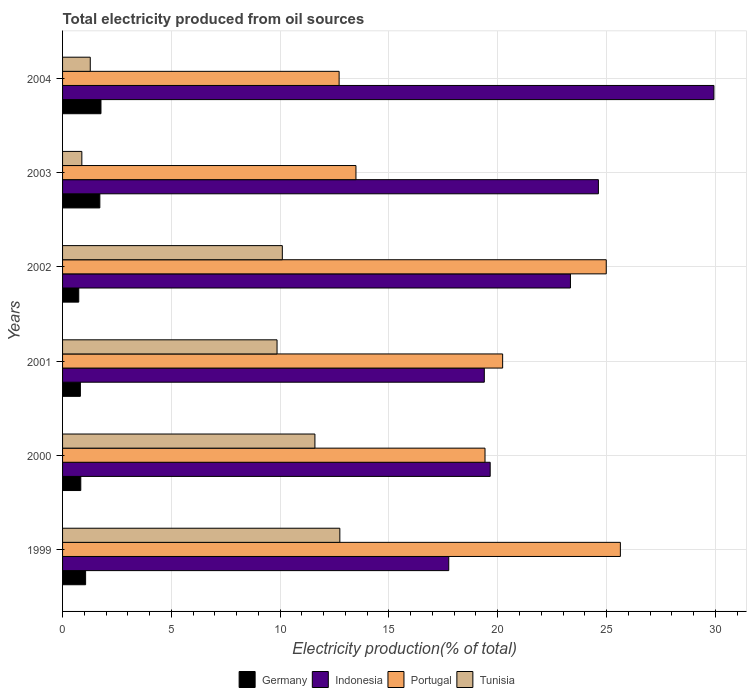What is the label of the 3rd group of bars from the top?
Offer a very short reply. 2002. In how many cases, is the number of bars for a given year not equal to the number of legend labels?
Offer a very short reply. 0. What is the total electricity produced in Indonesia in 2000?
Provide a succinct answer. 19.65. Across all years, what is the maximum total electricity produced in Tunisia?
Your answer should be compact. 12.74. Across all years, what is the minimum total electricity produced in Germany?
Provide a succinct answer. 0.74. What is the total total electricity produced in Tunisia in the graph?
Offer a terse response. 46.46. What is the difference between the total electricity produced in Portugal in 2003 and that in 2004?
Provide a succinct answer. 0.77. What is the difference between the total electricity produced in Portugal in 1999 and the total electricity produced in Indonesia in 2003?
Offer a terse response. 1.01. What is the average total electricity produced in Portugal per year?
Ensure brevity in your answer.  19.41. In the year 2003, what is the difference between the total electricity produced in Tunisia and total electricity produced in Indonesia?
Your answer should be very brief. -23.74. In how many years, is the total electricity produced in Tunisia greater than 28 %?
Provide a short and direct response. 0. What is the ratio of the total electricity produced in Germany in 2001 to that in 2002?
Your response must be concise. 1.1. Is the difference between the total electricity produced in Tunisia in 2000 and 2003 greater than the difference between the total electricity produced in Indonesia in 2000 and 2003?
Your answer should be very brief. Yes. What is the difference between the highest and the second highest total electricity produced in Germany?
Your answer should be very brief. 0.05. What is the difference between the highest and the lowest total electricity produced in Portugal?
Your answer should be very brief. 12.93. Is the sum of the total electricity produced in Portugal in 2001 and 2003 greater than the maximum total electricity produced in Tunisia across all years?
Provide a succinct answer. Yes. Is it the case that in every year, the sum of the total electricity produced in Germany and total electricity produced in Indonesia is greater than the sum of total electricity produced in Portugal and total electricity produced in Tunisia?
Your answer should be very brief. No. What does the 1st bar from the top in 2001 represents?
Provide a succinct answer. Tunisia. What does the 3rd bar from the bottom in 1999 represents?
Offer a very short reply. Portugal. Is it the case that in every year, the sum of the total electricity produced in Portugal and total electricity produced in Indonesia is greater than the total electricity produced in Tunisia?
Ensure brevity in your answer.  Yes. How many bars are there?
Provide a succinct answer. 24. Are all the bars in the graph horizontal?
Your response must be concise. Yes. How many years are there in the graph?
Your answer should be compact. 6. What is the difference between two consecutive major ticks on the X-axis?
Offer a terse response. 5. Does the graph contain any zero values?
Your response must be concise. No. Does the graph contain grids?
Give a very brief answer. Yes. Where does the legend appear in the graph?
Offer a very short reply. Bottom center. How many legend labels are there?
Your answer should be compact. 4. What is the title of the graph?
Ensure brevity in your answer.  Total electricity produced from oil sources. What is the Electricity production(% of total) in Germany in 1999?
Offer a terse response. 1.06. What is the Electricity production(% of total) of Indonesia in 1999?
Provide a short and direct response. 17.75. What is the Electricity production(% of total) in Portugal in 1999?
Your answer should be very brief. 25.64. What is the Electricity production(% of total) of Tunisia in 1999?
Make the answer very short. 12.74. What is the Electricity production(% of total) of Germany in 2000?
Ensure brevity in your answer.  0.84. What is the Electricity production(% of total) of Indonesia in 2000?
Offer a very short reply. 19.65. What is the Electricity production(% of total) of Portugal in 2000?
Offer a very short reply. 19.42. What is the Electricity production(% of total) of Tunisia in 2000?
Offer a very short reply. 11.6. What is the Electricity production(% of total) of Germany in 2001?
Offer a very short reply. 0.82. What is the Electricity production(% of total) in Indonesia in 2001?
Make the answer very short. 19.38. What is the Electricity production(% of total) of Portugal in 2001?
Give a very brief answer. 20.23. What is the Electricity production(% of total) of Tunisia in 2001?
Offer a very short reply. 9.86. What is the Electricity production(% of total) in Germany in 2002?
Make the answer very short. 0.74. What is the Electricity production(% of total) of Indonesia in 2002?
Your answer should be compact. 23.34. What is the Electricity production(% of total) in Portugal in 2002?
Your response must be concise. 24.99. What is the Electricity production(% of total) in Tunisia in 2002?
Your response must be concise. 10.1. What is the Electricity production(% of total) of Germany in 2003?
Your answer should be very brief. 1.71. What is the Electricity production(% of total) in Indonesia in 2003?
Make the answer very short. 24.63. What is the Electricity production(% of total) in Portugal in 2003?
Ensure brevity in your answer.  13.48. What is the Electricity production(% of total) of Tunisia in 2003?
Provide a succinct answer. 0.89. What is the Electricity production(% of total) in Germany in 2004?
Provide a short and direct response. 1.77. What is the Electricity production(% of total) in Indonesia in 2004?
Your answer should be very brief. 29.94. What is the Electricity production(% of total) of Portugal in 2004?
Your answer should be compact. 12.71. What is the Electricity production(% of total) of Tunisia in 2004?
Your answer should be very brief. 1.27. Across all years, what is the maximum Electricity production(% of total) of Germany?
Provide a succinct answer. 1.77. Across all years, what is the maximum Electricity production(% of total) of Indonesia?
Your answer should be very brief. 29.94. Across all years, what is the maximum Electricity production(% of total) of Portugal?
Your response must be concise. 25.64. Across all years, what is the maximum Electricity production(% of total) of Tunisia?
Provide a succinct answer. 12.74. Across all years, what is the minimum Electricity production(% of total) of Germany?
Keep it short and to the point. 0.74. Across all years, what is the minimum Electricity production(% of total) in Indonesia?
Provide a short and direct response. 17.75. Across all years, what is the minimum Electricity production(% of total) of Portugal?
Make the answer very short. 12.71. Across all years, what is the minimum Electricity production(% of total) of Tunisia?
Your answer should be compact. 0.89. What is the total Electricity production(% of total) in Germany in the graph?
Offer a very short reply. 6.94. What is the total Electricity production(% of total) in Indonesia in the graph?
Keep it short and to the point. 134.69. What is the total Electricity production(% of total) in Portugal in the graph?
Your answer should be very brief. 116.46. What is the total Electricity production(% of total) in Tunisia in the graph?
Your answer should be very brief. 46.46. What is the difference between the Electricity production(% of total) of Germany in 1999 and that in 2000?
Your response must be concise. 0.22. What is the difference between the Electricity production(% of total) in Indonesia in 1999 and that in 2000?
Offer a very short reply. -1.91. What is the difference between the Electricity production(% of total) in Portugal in 1999 and that in 2000?
Provide a short and direct response. 6.22. What is the difference between the Electricity production(% of total) in Tunisia in 1999 and that in 2000?
Offer a very short reply. 1.15. What is the difference between the Electricity production(% of total) in Germany in 1999 and that in 2001?
Offer a very short reply. 0.24. What is the difference between the Electricity production(% of total) in Indonesia in 1999 and that in 2001?
Offer a terse response. -1.64. What is the difference between the Electricity production(% of total) in Portugal in 1999 and that in 2001?
Give a very brief answer. 5.41. What is the difference between the Electricity production(% of total) in Tunisia in 1999 and that in 2001?
Ensure brevity in your answer.  2.89. What is the difference between the Electricity production(% of total) in Germany in 1999 and that in 2002?
Make the answer very short. 0.32. What is the difference between the Electricity production(% of total) in Indonesia in 1999 and that in 2002?
Provide a succinct answer. -5.59. What is the difference between the Electricity production(% of total) in Portugal in 1999 and that in 2002?
Ensure brevity in your answer.  0.65. What is the difference between the Electricity production(% of total) of Tunisia in 1999 and that in 2002?
Give a very brief answer. 2.64. What is the difference between the Electricity production(% of total) in Germany in 1999 and that in 2003?
Keep it short and to the point. -0.65. What is the difference between the Electricity production(% of total) of Indonesia in 1999 and that in 2003?
Offer a very short reply. -6.88. What is the difference between the Electricity production(% of total) in Portugal in 1999 and that in 2003?
Offer a very short reply. 12.15. What is the difference between the Electricity production(% of total) of Tunisia in 1999 and that in 2003?
Keep it short and to the point. 11.86. What is the difference between the Electricity production(% of total) of Germany in 1999 and that in 2004?
Give a very brief answer. -0.71. What is the difference between the Electricity production(% of total) of Indonesia in 1999 and that in 2004?
Offer a terse response. -12.19. What is the difference between the Electricity production(% of total) in Portugal in 1999 and that in 2004?
Your answer should be very brief. 12.93. What is the difference between the Electricity production(% of total) of Tunisia in 1999 and that in 2004?
Provide a short and direct response. 11.47. What is the difference between the Electricity production(% of total) in Germany in 2000 and that in 2001?
Offer a very short reply. 0.02. What is the difference between the Electricity production(% of total) of Indonesia in 2000 and that in 2001?
Offer a terse response. 0.27. What is the difference between the Electricity production(% of total) of Portugal in 2000 and that in 2001?
Provide a succinct answer. -0.81. What is the difference between the Electricity production(% of total) of Tunisia in 2000 and that in 2001?
Your response must be concise. 1.74. What is the difference between the Electricity production(% of total) in Germany in 2000 and that in 2002?
Make the answer very short. 0.09. What is the difference between the Electricity production(% of total) in Indonesia in 2000 and that in 2002?
Offer a very short reply. -3.69. What is the difference between the Electricity production(% of total) in Portugal in 2000 and that in 2002?
Provide a short and direct response. -5.57. What is the difference between the Electricity production(% of total) of Tunisia in 2000 and that in 2002?
Offer a very short reply. 1.5. What is the difference between the Electricity production(% of total) in Germany in 2000 and that in 2003?
Give a very brief answer. -0.88. What is the difference between the Electricity production(% of total) of Indonesia in 2000 and that in 2003?
Offer a terse response. -4.97. What is the difference between the Electricity production(% of total) of Portugal in 2000 and that in 2003?
Your answer should be compact. 5.93. What is the difference between the Electricity production(% of total) of Tunisia in 2000 and that in 2003?
Your answer should be compact. 10.71. What is the difference between the Electricity production(% of total) of Germany in 2000 and that in 2004?
Keep it short and to the point. -0.93. What is the difference between the Electricity production(% of total) in Indonesia in 2000 and that in 2004?
Give a very brief answer. -10.28. What is the difference between the Electricity production(% of total) of Portugal in 2000 and that in 2004?
Offer a very short reply. 6.7. What is the difference between the Electricity production(% of total) of Tunisia in 2000 and that in 2004?
Offer a very short reply. 10.33. What is the difference between the Electricity production(% of total) in Germany in 2001 and that in 2002?
Provide a short and direct response. 0.07. What is the difference between the Electricity production(% of total) of Indonesia in 2001 and that in 2002?
Keep it short and to the point. -3.96. What is the difference between the Electricity production(% of total) of Portugal in 2001 and that in 2002?
Your answer should be compact. -4.76. What is the difference between the Electricity production(% of total) in Tunisia in 2001 and that in 2002?
Offer a very short reply. -0.24. What is the difference between the Electricity production(% of total) in Germany in 2001 and that in 2003?
Your response must be concise. -0.9. What is the difference between the Electricity production(% of total) in Indonesia in 2001 and that in 2003?
Your answer should be very brief. -5.24. What is the difference between the Electricity production(% of total) of Portugal in 2001 and that in 2003?
Offer a very short reply. 6.74. What is the difference between the Electricity production(% of total) in Tunisia in 2001 and that in 2003?
Your response must be concise. 8.97. What is the difference between the Electricity production(% of total) in Germany in 2001 and that in 2004?
Provide a short and direct response. -0.95. What is the difference between the Electricity production(% of total) of Indonesia in 2001 and that in 2004?
Offer a terse response. -10.55. What is the difference between the Electricity production(% of total) of Portugal in 2001 and that in 2004?
Provide a short and direct response. 7.51. What is the difference between the Electricity production(% of total) of Tunisia in 2001 and that in 2004?
Provide a succinct answer. 8.58. What is the difference between the Electricity production(% of total) of Germany in 2002 and that in 2003?
Provide a short and direct response. -0.97. What is the difference between the Electricity production(% of total) in Indonesia in 2002 and that in 2003?
Your answer should be very brief. -1.28. What is the difference between the Electricity production(% of total) of Portugal in 2002 and that in 2003?
Provide a short and direct response. 11.5. What is the difference between the Electricity production(% of total) of Tunisia in 2002 and that in 2003?
Make the answer very short. 9.21. What is the difference between the Electricity production(% of total) in Germany in 2002 and that in 2004?
Give a very brief answer. -1.02. What is the difference between the Electricity production(% of total) in Indonesia in 2002 and that in 2004?
Keep it short and to the point. -6.59. What is the difference between the Electricity production(% of total) in Portugal in 2002 and that in 2004?
Provide a succinct answer. 12.28. What is the difference between the Electricity production(% of total) of Tunisia in 2002 and that in 2004?
Provide a succinct answer. 8.83. What is the difference between the Electricity production(% of total) in Germany in 2003 and that in 2004?
Provide a succinct answer. -0.05. What is the difference between the Electricity production(% of total) of Indonesia in 2003 and that in 2004?
Your answer should be very brief. -5.31. What is the difference between the Electricity production(% of total) in Portugal in 2003 and that in 2004?
Give a very brief answer. 0.77. What is the difference between the Electricity production(% of total) in Tunisia in 2003 and that in 2004?
Offer a terse response. -0.39. What is the difference between the Electricity production(% of total) in Germany in 1999 and the Electricity production(% of total) in Indonesia in 2000?
Your answer should be very brief. -18.59. What is the difference between the Electricity production(% of total) of Germany in 1999 and the Electricity production(% of total) of Portugal in 2000?
Provide a succinct answer. -18.36. What is the difference between the Electricity production(% of total) of Germany in 1999 and the Electricity production(% of total) of Tunisia in 2000?
Ensure brevity in your answer.  -10.54. What is the difference between the Electricity production(% of total) of Indonesia in 1999 and the Electricity production(% of total) of Portugal in 2000?
Your response must be concise. -1.67. What is the difference between the Electricity production(% of total) of Indonesia in 1999 and the Electricity production(% of total) of Tunisia in 2000?
Make the answer very short. 6.15. What is the difference between the Electricity production(% of total) of Portugal in 1999 and the Electricity production(% of total) of Tunisia in 2000?
Your response must be concise. 14.04. What is the difference between the Electricity production(% of total) of Germany in 1999 and the Electricity production(% of total) of Indonesia in 2001?
Your answer should be compact. -18.32. What is the difference between the Electricity production(% of total) in Germany in 1999 and the Electricity production(% of total) in Portugal in 2001?
Make the answer very short. -19.17. What is the difference between the Electricity production(% of total) in Germany in 1999 and the Electricity production(% of total) in Tunisia in 2001?
Provide a short and direct response. -8.8. What is the difference between the Electricity production(% of total) in Indonesia in 1999 and the Electricity production(% of total) in Portugal in 2001?
Your response must be concise. -2.48. What is the difference between the Electricity production(% of total) of Indonesia in 1999 and the Electricity production(% of total) of Tunisia in 2001?
Give a very brief answer. 7.89. What is the difference between the Electricity production(% of total) in Portugal in 1999 and the Electricity production(% of total) in Tunisia in 2001?
Ensure brevity in your answer.  15.78. What is the difference between the Electricity production(% of total) of Germany in 1999 and the Electricity production(% of total) of Indonesia in 2002?
Your answer should be compact. -22.28. What is the difference between the Electricity production(% of total) of Germany in 1999 and the Electricity production(% of total) of Portugal in 2002?
Ensure brevity in your answer.  -23.93. What is the difference between the Electricity production(% of total) of Germany in 1999 and the Electricity production(% of total) of Tunisia in 2002?
Your answer should be compact. -9.04. What is the difference between the Electricity production(% of total) of Indonesia in 1999 and the Electricity production(% of total) of Portugal in 2002?
Provide a short and direct response. -7.24. What is the difference between the Electricity production(% of total) of Indonesia in 1999 and the Electricity production(% of total) of Tunisia in 2002?
Offer a very short reply. 7.65. What is the difference between the Electricity production(% of total) in Portugal in 1999 and the Electricity production(% of total) in Tunisia in 2002?
Ensure brevity in your answer.  15.54. What is the difference between the Electricity production(% of total) of Germany in 1999 and the Electricity production(% of total) of Indonesia in 2003?
Ensure brevity in your answer.  -23.57. What is the difference between the Electricity production(% of total) of Germany in 1999 and the Electricity production(% of total) of Portugal in 2003?
Offer a very short reply. -12.43. What is the difference between the Electricity production(% of total) of Germany in 1999 and the Electricity production(% of total) of Tunisia in 2003?
Offer a terse response. 0.17. What is the difference between the Electricity production(% of total) in Indonesia in 1999 and the Electricity production(% of total) in Portugal in 2003?
Your answer should be compact. 4.26. What is the difference between the Electricity production(% of total) of Indonesia in 1999 and the Electricity production(% of total) of Tunisia in 2003?
Offer a terse response. 16.86. What is the difference between the Electricity production(% of total) of Portugal in 1999 and the Electricity production(% of total) of Tunisia in 2003?
Offer a terse response. 24.75. What is the difference between the Electricity production(% of total) in Germany in 1999 and the Electricity production(% of total) in Indonesia in 2004?
Your response must be concise. -28.88. What is the difference between the Electricity production(% of total) in Germany in 1999 and the Electricity production(% of total) in Portugal in 2004?
Provide a succinct answer. -11.65. What is the difference between the Electricity production(% of total) of Germany in 1999 and the Electricity production(% of total) of Tunisia in 2004?
Ensure brevity in your answer.  -0.21. What is the difference between the Electricity production(% of total) in Indonesia in 1999 and the Electricity production(% of total) in Portugal in 2004?
Offer a very short reply. 5.04. What is the difference between the Electricity production(% of total) in Indonesia in 1999 and the Electricity production(% of total) in Tunisia in 2004?
Give a very brief answer. 16.48. What is the difference between the Electricity production(% of total) in Portugal in 1999 and the Electricity production(% of total) in Tunisia in 2004?
Offer a very short reply. 24.36. What is the difference between the Electricity production(% of total) of Germany in 2000 and the Electricity production(% of total) of Indonesia in 2001?
Provide a succinct answer. -18.55. What is the difference between the Electricity production(% of total) of Germany in 2000 and the Electricity production(% of total) of Portugal in 2001?
Your response must be concise. -19.39. What is the difference between the Electricity production(% of total) in Germany in 2000 and the Electricity production(% of total) in Tunisia in 2001?
Your answer should be compact. -9.02. What is the difference between the Electricity production(% of total) of Indonesia in 2000 and the Electricity production(% of total) of Portugal in 2001?
Give a very brief answer. -0.57. What is the difference between the Electricity production(% of total) of Indonesia in 2000 and the Electricity production(% of total) of Tunisia in 2001?
Ensure brevity in your answer.  9.8. What is the difference between the Electricity production(% of total) of Portugal in 2000 and the Electricity production(% of total) of Tunisia in 2001?
Offer a terse response. 9.56. What is the difference between the Electricity production(% of total) in Germany in 2000 and the Electricity production(% of total) in Indonesia in 2002?
Keep it short and to the point. -22.51. What is the difference between the Electricity production(% of total) of Germany in 2000 and the Electricity production(% of total) of Portugal in 2002?
Your response must be concise. -24.15. What is the difference between the Electricity production(% of total) in Germany in 2000 and the Electricity production(% of total) in Tunisia in 2002?
Give a very brief answer. -9.26. What is the difference between the Electricity production(% of total) of Indonesia in 2000 and the Electricity production(% of total) of Portugal in 2002?
Your answer should be very brief. -5.33. What is the difference between the Electricity production(% of total) of Indonesia in 2000 and the Electricity production(% of total) of Tunisia in 2002?
Keep it short and to the point. 9.55. What is the difference between the Electricity production(% of total) of Portugal in 2000 and the Electricity production(% of total) of Tunisia in 2002?
Offer a terse response. 9.32. What is the difference between the Electricity production(% of total) in Germany in 2000 and the Electricity production(% of total) in Indonesia in 2003?
Make the answer very short. -23.79. What is the difference between the Electricity production(% of total) of Germany in 2000 and the Electricity production(% of total) of Portugal in 2003?
Offer a terse response. -12.65. What is the difference between the Electricity production(% of total) in Germany in 2000 and the Electricity production(% of total) in Tunisia in 2003?
Give a very brief answer. -0.05. What is the difference between the Electricity production(% of total) of Indonesia in 2000 and the Electricity production(% of total) of Portugal in 2003?
Keep it short and to the point. 6.17. What is the difference between the Electricity production(% of total) in Indonesia in 2000 and the Electricity production(% of total) in Tunisia in 2003?
Your answer should be very brief. 18.77. What is the difference between the Electricity production(% of total) in Portugal in 2000 and the Electricity production(% of total) in Tunisia in 2003?
Offer a very short reply. 18.53. What is the difference between the Electricity production(% of total) in Germany in 2000 and the Electricity production(% of total) in Indonesia in 2004?
Give a very brief answer. -29.1. What is the difference between the Electricity production(% of total) in Germany in 2000 and the Electricity production(% of total) in Portugal in 2004?
Provide a succinct answer. -11.87. What is the difference between the Electricity production(% of total) in Germany in 2000 and the Electricity production(% of total) in Tunisia in 2004?
Offer a terse response. -0.44. What is the difference between the Electricity production(% of total) in Indonesia in 2000 and the Electricity production(% of total) in Portugal in 2004?
Make the answer very short. 6.94. What is the difference between the Electricity production(% of total) of Indonesia in 2000 and the Electricity production(% of total) of Tunisia in 2004?
Give a very brief answer. 18.38. What is the difference between the Electricity production(% of total) of Portugal in 2000 and the Electricity production(% of total) of Tunisia in 2004?
Provide a succinct answer. 18.14. What is the difference between the Electricity production(% of total) in Germany in 2001 and the Electricity production(% of total) in Indonesia in 2002?
Make the answer very short. -22.52. What is the difference between the Electricity production(% of total) in Germany in 2001 and the Electricity production(% of total) in Portugal in 2002?
Your answer should be very brief. -24.17. What is the difference between the Electricity production(% of total) in Germany in 2001 and the Electricity production(% of total) in Tunisia in 2002?
Your answer should be compact. -9.28. What is the difference between the Electricity production(% of total) in Indonesia in 2001 and the Electricity production(% of total) in Portugal in 2002?
Provide a short and direct response. -5.6. What is the difference between the Electricity production(% of total) of Indonesia in 2001 and the Electricity production(% of total) of Tunisia in 2002?
Provide a short and direct response. 9.28. What is the difference between the Electricity production(% of total) in Portugal in 2001 and the Electricity production(% of total) in Tunisia in 2002?
Offer a very short reply. 10.13. What is the difference between the Electricity production(% of total) of Germany in 2001 and the Electricity production(% of total) of Indonesia in 2003?
Your answer should be compact. -23.81. What is the difference between the Electricity production(% of total) in Germany in 2001 and the Electricity production(% of total) in Portugal in 2003?
Ensure brevity in your answer.  -12.67. What is the difference between the Electricity production(% of total) of Germany in 2001 and the Electricity production(% of total) of Tunisia in 2003?
Offer a terse response. -0.07. What is the difference between the Electricity production(% of total) in Indonesia in 2001 and the Electricity production(% of total) in Portugal in 2003?
Give a very brief answer. 5.9. What is the difference between the Electricity production(% of total) in Indonesia in 2001 and the Electricity production(% of total) in Tunisia in 2003?
Provide a short and direct response. 18.5. What is the difference between the Electricity production(% of total) of Portugal in 2001 and the Electricity production(% of total) of Tunisia in 2003?
Provide a short and direct response. 19.34. What is the difference between the Electricity production(% of total) in Germany in 2001 and the Electricity production(% of total) in Indonesia in 2004?
Keep it short and to the point. -29.12. What is the difference between the Electricity production(% of total) in Germany in 2001 and the Electricity production(% of total) in Portugal in 2004?
Your response must be concise. -11.89. What is the difference between the Electricity production(% of total) in Germany in 2001 and the Electricity production(% of total) in Tunisia in 2004?
Offer a terse response. -0.45. What is the difference between the Electricity production(% of total) in Indonesia in 2001 and the Electricity production(% of total) in Portugal in 2004?
Offer a very short reply. 6.67. What is the difference between the Electricity production(% of total) of Indonesia in 2001 and the Electricity production(% of total) of Tunisia in 2004?
Your answer should be very brief. 18.11. What is the difference between the Electricity production(% of total) of Portugal in 2001 and the Electricity production(% of total) of Tunisia in 2004?
Your answer should be compact. 18.95. What is the difference between the Electricity production(% of total) of Germany in 2002 and the Electricity production(% of total) of Indonesia in 2003?
Your answer should be compact. -23.88. What is the difference between the Electricity production(% of total) in Germany in 2002 and the Electricity production(% of total) in Portugal in 2003?
Your response must be concise. -12.74. What is the difference between the Electricity production(% of total) of Germany in 2002 and the Electricity production(% of total) of Tunisia in 2003?
Offer a very short reply. -0.14. What is the difference between the Electricity production(% of total) in Indonesia in 2002 and the Electricity production(% of total) in Portugal in 2003?
Provide a succinct answer. 9.86. What is the difference between the Electricity production(% of total) in Indonesia in 2002 and the Electricity production(% of total) in Tunisia in 2003?
Keep it short and to the point. 22.46. What is the difference between the Electricity production(% of total) of Portugal in 2002 and the Electricity production(% of total) of Tunisia in 2003?
Offer a very short reply. 24.1. What is the difference between the Electricity production(% of total) in Germany in 2002 and the Electricity production(% of total) in Indonesia in 2004?
Your answer should be very brief. -29.19. What is the difference between the Electricity production(% of total) of Germany in 2002 and the Electricity production(% of total) of Portugal in 2004?
Make the answer very short. -11.97. What is the difference between the Electricity production(% of total) of Germany in 2002 and the Electricity production(% of total) of Tunisia in 2004?
Your answer should be very brief. -0.53. What is the difference between the Electricity production(% of total) in Indonesia in 2002 and the Electricity production(% of total) in Portugal in 2004?
Offer a terse response. 10.63. What is the difference between the Electricity production(% of total) of Indonesia in 2002 and the Electricity production(% of total) of Tunisia in 2004?
Provide a succinct answer. 22.07. What is the difference between the Electricity production(% of total) in Portugal in 2002 and the Electricity production(% of total) in Tunisia in 2004?
Provide a short and direct response. 23.71. What is the difference between the Electricity production(% of total) of Germany in 2003 and the Electricity production(% of total) of Indonesia in 2004?
Offer a terse response. -28.22. What is the difference between the Electricity production(% of total) in Germany in 2003 and the Electricity production(% of total) in Portugal in 2004?
Ensure brevity in your answer.  -11. What is the difference between the Electricity production(% of total) of Germany in 2003 and the Electricity production(% of total) of Tunisia in 2004?
Your response must be concise. 0.44. What is the difference between the Electricity production(% of total) in Indonesia in 2003 and the Electricity production(% of total) in Portugal in 2004?
Make the answer very short. 11.92. What is the difference between the Electricity production(% of total) in Indonesia in 2003 and the Electricity production(% of total) in Tunisia in 2004?
Provide a short and direct response. 23.35. What is the difference between the Electricity production(% of total) in Portugal in 2003 and the Electricity production(% of total) in Tunisia in 2004?
Offer a very short reply. 12.21. What is the average Electricity production(% of total) of Germany per year?
Give a very brief answer. 1.16. What is the average Electricity production(% of total) of Indonesia per year?
Your answer should be compact. 22.45. What is the average Electricity production(% of total) of Portugal per year?
Offer a very short reply. 19.41. What is the average Electricity production(% of total) of Tunisia per year?
Your answer should be very brief. 7.74. In the year 1999, what is the difference between the Electricity production(% of total) in Germany and Electricity production(% of total) in Indonesia?
Provide a short and direct response. -16.69. In the year 1999, what is the difference between the Electricity production(% of total) in Germany and Electricity production(% of total) in Portugal?
Make the answer very short. -24.58. In the year 1999, what is the difference between the Electricity production(% of total) in Germany and Electricity production(% of total) in Tunisia?
Provide a succinct answer. -11.68. In the year 1999, what is the difference between the Electricity production(% of total) in Indonesia and Electricity production(% of total) in Portugal?
Your answer should be very brief. -7.89. In the year 1999, what is the difference between the Electricity production(% of total) in Indonesia and Electricity production(% of total) in Tunisia?
Offer a very short reply. 5.01. In the year 1999, what is the difference between the Electricity production(% of total) in Portugal and Electricity production(% of total) in Tunisia?
Offer a very short reply. 12.89. In the year 2000, what is the difference between the Electricity production(% of total) of Germany and Electricity production(% of total) of Indonesia?
Provide a succinct answer. -18.82. In the year 2000, what is the difference between the Electricity production(% of total) of Germany and Electricity production(% of total) of Portugal?
Offer a very short reply. -18.58. In the year 2000, what is the difference between the Electricity production(% of total) in Germany and Electricity production(% of total) in Tunisia?
Provide a short and direct response. -10.76. In the year 2000, what is the difference between the Electricity production(% of total) of Indonesia and Electricity production(% of total) of Portugal?
Offer a very short reply. 0.24. In the year 2000, what is the difference between the Electricity production(% of total) in Indonesia and Electricity production(% of total) in Tunisia?
Your answer should be compact. 8.06. In the year 2000, what is the difference between the Electricity production(% of total) in Portugal and Electricity production(% of total) in Tunisia?
Your response must be concise. 7.82. In the year 2001, what is the difference between the Electricity production(% of total) in Germany and Electricity production(% of total) in Indonesia?
Provide a short and direct response. -18.57. In the year 2001, what is the difference between the Electricity production(% of total) of Germany and Electricity production(% of total) of Portugal?
Your response must be concise. -19.41. In the year 2001, what is the difference between the Electricity production(% of total) in Germany and Electricity production(% of total) in Tunisia?
Offer a terse response. -9.04. In the year 2001, what is the difference between the Electricity production(% of total) in Indonesia and Electricity production(% of total) in Portugal?
Provide a succinct answer. -0.84. In the year 2001, what is the difference between the Electricity production(% of total) in Indonesia and Electricity production(% of total) in Tunisia?
Provide a short and direct response. 9.53. In the year 2001, what is the difference between the Electricity production(% of total) of Portugal and Electricity production(% of total) of Tunisia?
Provide a succinct answer. 10.37. In the year 2002, what is the difference between the Electricity production(% of total) in Germany and Electricity production(% of total) in Indonesia?
Your answer should be compact. -22.6. In the year 2002, what is the difference between the Electricity production(% of total) in Germany and Electricity production(% of total) in Portugal?
Provide a short and direct response. -24.24. In the year 2002, what is the difference between the Electricity production(% of total) in Germany and Electricity production(% of total) in Tunisia?
Offer a terse response. -9.36. In the year 2002, what is the difference between the Electricity production(% of total) of Indonesia and Electricity production(% of total) of Portugal?
Keep it short and to the point. -1.65. In the year 2002, what is the difference between the Electricity production(% of total) in Indonesia and Electricity production(% of total) in Tunisia?
Offer a very short reply. 13.24. In the year 2002, what is the difference between the Electricity production(% of total) of Portugal and Electricity production(% of total) of Tunisia?
Your answer should be compact. 14.89. In the year 2003, what is the difference between the Electricity production(% of total) in Germany and Electricity production(% of total) in Indonesia?
Your answer should be very brief. -22.91. In the year 2003, what is the difference between the Electricity production(% of total) in Germany and Electricity production(% of total) in Portugal?
Keep it short and to the point. -11.77. In the year 2003, what is the difference between the Electricity production(% of total) of Germany and Electricity production(% of total) of Tunisia?
Ensure brevity in your answer.  0.83. In the year 2003, what is the difference between the Electricity production(% of total) in Indonesia and Electricity production(% of total) in Portugal?
Your response must be concise. 11.14. In the year 2003, what is the difference between the Electricity production(% of total) of Indonesia and Electricity production(% of total) of Tunisia?
Make the answer very short. 23.74. In the year 2003, what is the difference between the Electricity production(% of total) of Portugal and Electricity production(% of total) of Tunisia?
Make the answer very short. 12.6. In the year 2004, what is the difference between the Electricity production(% of total) of Germany and Electricity production(% of total) of Indonesia?
Make the answer very short. -28.17. In the year 2004, what is the difference between the Electricity production(% of total) in Germany and Electricity production(% of total) in Portugal?
Provide a succinct answer. -10.95. In the year 2004, what is the difference between the Electricity production(% of total) of Germany and Electricity production(% of total) of Tunisia?
Provide a succinct answer. 0.49. In the year 2004, what is the difference between the Electricity production(% of total) in Indonesia and Electricity production(% of total) in Portugal?
Offer a very short reply. 17.23. In the year 2004, what is the difference between the Electricity production(% of total) in Indonesia and Electricity production(% of total) in Tunisia?
Give a very brief answer. 28.66. In the year 2004, what is the difference between the Electricity production(% of total) of Portugal and Electricity production(% of total) of Tunisia?
Ensure brevity in your answer.  11.44. What is the ratio of the Electricity production(% of total) of Germany in 1999 to that in 2000?
Give a very brief answer. 1.27. What is the ratio of the Electricity production(% of total) in Indonesia in 1999 to that in 2000?
Offer a terse response. 0.9. What is the ratio of the Electricity production(% of total) in Portugal in 1999 to that in 2000?
Provide a succinct answer. 1.32. What is the ratio of the Electricity production(% of total) in Tunisia in 1999 to that in 2000?
Provide a short and direct response. 1.1. What is the ratio of the Electricity production(% of total) in Germany in 1999 to that in 2001?
Your answer should be very brief. 1.29. What is the ratio of the Electricity production(% of total) in Indonesia in 1999 to that in 2001?
Keep it short and to the point. 0.92. What is the ratio of the Electricity production(% of total) of Portugal in 1999 to that in 2001?
Provide a succinct answer. 1.27. What is the ratio of the Electricity production(% of total) of Tunisia in 1999 to that in 2001?
Keep it short and to the point. 1.29. What is the ratio of the Electricity production(% of total) in Germany in 1999 to that in 2002?
Give a very brief answer. 1.42. What is the ratio of the Electricity production(% of total) of Indonesia in 1999 to that in 2002?
Make the answer very short. 0.76. What is the ratio of the Electricity production(% of total) in Tunisia in 1999 to that in 2002?
Give a very brief answer. 1.26. What is the ratio of the Electricity production(% of total) in Germany in 1999 to that in 2003?
Give a very brief answer. 0.62. What is the ratio of the Electricity production(% of total) in Indonesia in 1999 to that in 2003?
Provide a short and direct response. 0.72. What is the ratio of the Electricity production(% of total) of Portugal in 1999 to that in 2003?
Offer a very short reply. 1.9. What is the ratio of the Electricity production(% of total) in Tunisia in 1999 to that in 2003?
Your answer should be very brief. 14.39. What is the ratio of the Electricity production(% of total) of Germany in 1999 to that in 2004?
Offer a very short reply. 0.6. What is the ratio of the Electricity production(% of total) of Indonesia in 1999 to that in 2004?
Your response must be concise. 0.59. What is the ratio of the Electricity production(% of total) of Portugal in 1999 to that in 2004?
Your response must be concise. 2.02. What is the ratio of the Electricity production(% of total) of Tunisia in 1999 to that in 2004?
Your answer should be very brief. 10.01. What is the ratio of the Electricity production(% of total) of Germany in 2000 to that in 2001?
Your answer should be very brief. 1.02. What is the ratio of the Electricity production(% of total) of Indonesia in 2000 to that in 2001?
Offer a terse response. 1.01. What is the ratio of the Electricity production(% of total) in Portugal in 2000 to that in 2001?
Provide a short and direct response. 0.96. What is the ratio of the Electricity production(% of total) in Tunisia in 2000 to that in 2001?
Give a very brief answer. 1.18. What is the ratio of the Electricity production(% of total) in Germany in 2000 to that in 2002?
Your answer should be very brief. 1.13. What is the ratio of the Electricity production(% of total) in Indonesia in 2000 to that in 2002?
Give a very brief answer. 0.84. What is the ratio of the Electricity production(% of total) of Portugal in 2000 to that in 2002?
Offer a very short reply. 0.78. What is the ratio of the Electricity production(% of total) in Tunisia in 2000 to that in 2002?
Provide a short and direct response. 1.15. What is the ratio of the Electricity production(% of total) in Germany in 2000 to that in 2003?
Your answer should be compact. 0.49. What is the ratio of the Electricity production(% of total) in Indonesia in 2000 to that in 2003?
Provide a succinct answer. 0.8. What is the ratio of the Electricity production(% of total) in Portugal in 2000 to that in 2003?
Offer a terse response. 1.44. What is the ratio of the Electricity production(% of total) in Tunisia in 2000 to that in 2003?
Provide a succinct answer. 13.1. What is the ratio of the Electricity production(% of total) of Germany in 2000 to that in 2004?
Keep it short and to the point. 0.47. What is the ratio of the Electricity production(% of total) of Indonesia in 2000 to that in 2004?
Make the answer very short. 0.66. What is the ratio of the Electricity production(% of total) of Portugal in 2000 to that in 2004?
Provide a short and direct response. 1.53. What is the ratio of the Electricity production(% of total) in Tunisia in 2000 to that in 2004?
Make the answer very short. 9.11. What is the ratio of the Electricity production(% of total) of Germany in 2001 to that in 2002?
Offer a terse response. 1.1. What is the ratio of the Electricity production(% of total) of Indonesia in 2001 to that in 2002?
Ensure brevity in your answer.  0.83. What is the ratio of the Electricity production(% of total) of Portugal in 2001 to that in 2002?
Provide a succinct answer. 0.81. What is the ratio of the Electricity production(% of total) of Tunisia in 2001 to that in 2002?
Provide a succinct answer. 0.98. What is the ratio of the Electricity production(% of total) of Germany in 2001 to that in 2003?
Ensure brevity in your answer.  0.48. What is the ratio of the Electricity production(% of total) of Indonesia in 2001 to that in 2003?
Your response must be concise. 0.79. What is the ratio of the Electricity production(% of total) of Tunisia in 2001 to that in 2003?
Keep it short and to the point. 11.13. What is the ratio of the Electricity production(% of total) of Germany in 2001 to that in 2004?
Provide a succinct answer. 0.46. What is the ratio of the Electricity production(% of total) of Indonesia in 2001 to that in 2004?
Offer a terse response. 0.65. What is the ratio of the Electricity production(% of total) in Portugal in 2001 to that in 2004?
Offer a very short reply. 1.59. What is the ratio of the Electricity production(% of total) in Tunisia in 2001 to that in 2004?
Give a very brief answer. 7.74. What is the ratio of the Electricity production(% of total) of Germany in 2002 to that in 2003?
Your answer should be very brief. 0.43. What is the ratio of the Electricity production(% of total) of Indonesia in 2002 to that in 2003?
Offer a terse response. 0.95. What is the ratio of the Electricity production(% of total) in Portugal in 2002 to that in 2003?
Offer a very short reply. 1.85. What is the ratio of the Electricity production(% of total) of Tunisia in 2002 to that in 2003?
Ensure brevity in your answer.  11.4. What is the ratio of the Electricity production(% of total) of Germany in 2002 to that in 2004?
Offer a very short reply. 0.42. What is the ratio of the Electricity production(% of total) in Indonesia in 2002 to that in 2004?
Your response must be concise. 0.78. What is the ratio of the Electricity production(% of total) of Portugal in 2002 to that in 2004?
Your answer should be compact. 1.97. What is the ratio of the Electricity production(% of total) of Tunisia in 2002 to that in 2004?
Ensure brevity in your answer.  7.93. What is the ratio of the Electricity production(% of total) of Germany in 2003 to that in 2004?
Provide a succinct answer. 0.97. What is the ratio of the Electricity production(% of total) in Indonesia in 2003 to that in 2004?
Provide a short and direct response. 0.82. What is the ratio of the Electricity production(% of total) in Portugal in 2003 to that in 2004?
Give a very brief answer. 1.06. What is the ratio of the Electricity production(% of total) of Tunisia in 2003 to that in 2004?
Provide a short and direct response. 0.7. What is the difference between the highest and the second highest Electricity production(% of total) of Germany?
Your answer should be compact. 0.05. What is the difference between the highest and the second highest Electricity production(% of total) of Indonesia?
Your response must be concise. 5.31. What is the difference between the highest and the second highest Electricity production(% of total) of Portugal?
Give a very brief answer. 0.65. What is the difference between the highest and the second highest Electricity production(% of total) of Tunisia?
Offer a terse response. 1.15. What is the difference between the highest and the lowest Electricity production(% of total) in Germany?
Your answer should be very brief. 1.02. What is the difference between the highest and the lowest Electricity production(% of total) of Indonesia?
Your answer should be very brief. 12.19. What is the difference between the highest and the lowest Electricity production(% of total) in Portugal?
Make the answer very short. 12.93. What is the difference between the highest and the lowest Electricity production(% of total) of Tunisia?
Your response must be concise. 11.86. 